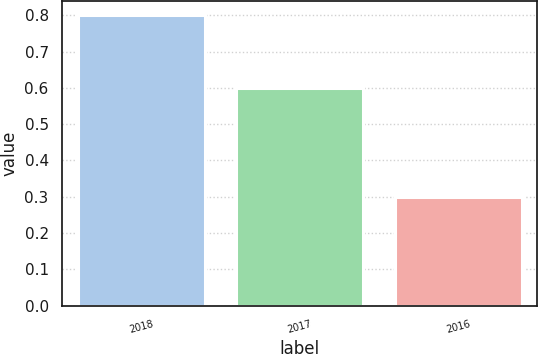<chart> <loc_0><loc_0><loc_500><loc_500><bar_chart><fcel>2018<fcel>2017<fcel>2016<nl><fcel>0.8<fcel>0.6<fcel>0.3<nl></chart> 